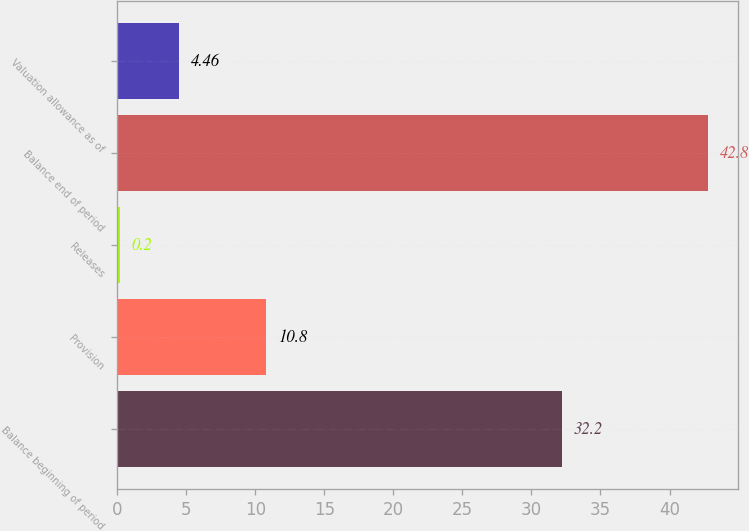Convert chart to OTSL. <chart><loc_0><loc_0><loc_500><loc_500><bar_chart><fcel>Balance beginning of period<fcel>Provision<fcel>Releases<fcel>Balance end of period<fcel>Valuation allowance as of<nl><fcel>32.2<fcel>10.8<fcel>0.2<fcel>42.8<fcel>4.46<nl></chart> 